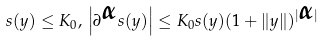Convert formula to latex. <formula><loc_0><loc_0><loc_500><loc_500>s ( y ) \leq K _ { 0 } , \, \left | \partial ^ { \boldsymbol \alpha } s ( y ) \right | \leq K _ { 0 } s ( y ) ( 1 + \| y \| ) ^ { | \boldsymbol \alpha | }</formula> 